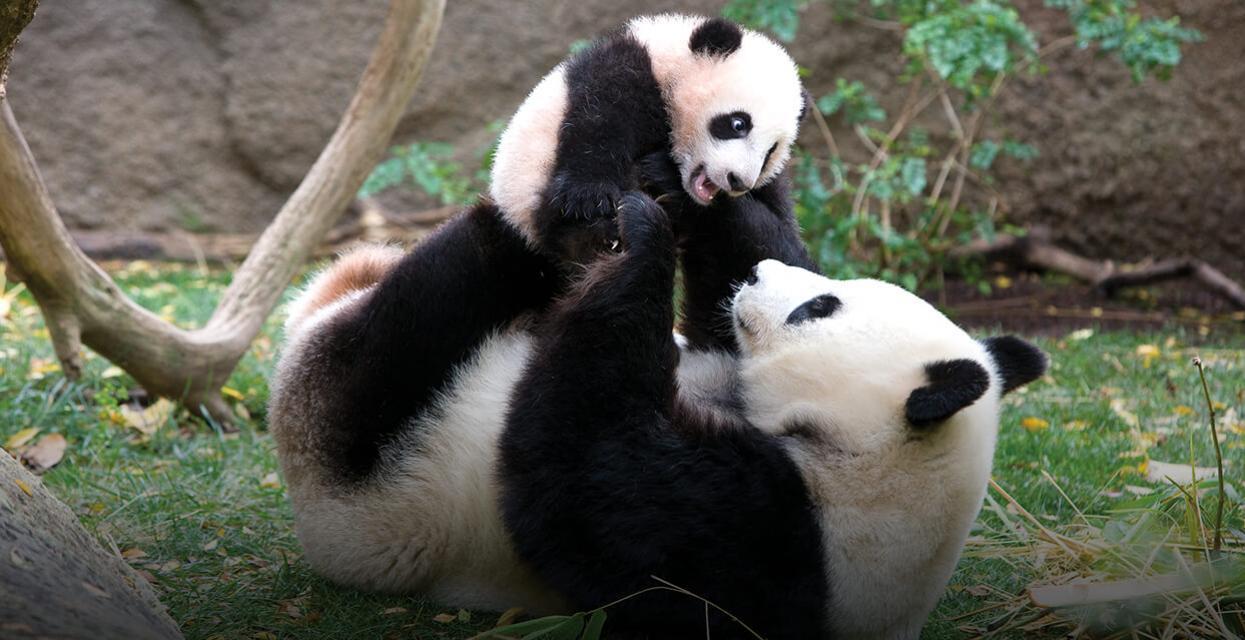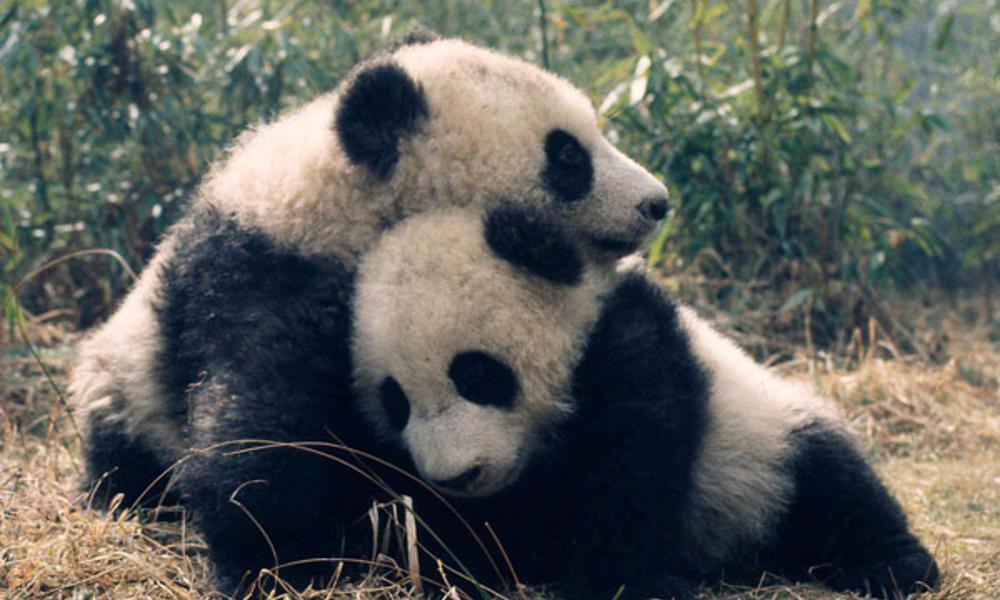The first image is the image on the left, the second image is the image on the right. Evaluate the accuracy of this statement regarding the images: "The panda is sitting on top of a tree branch in the right image.". Is it true? Answer yes or no. No. 